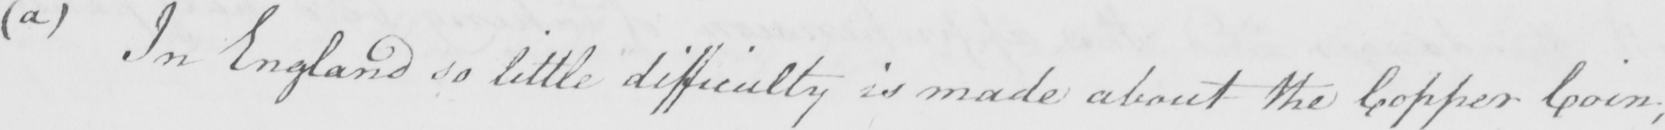What text is written in this handwritten line? ( a )  In England so little difficulty is made about the Copper Coin ; 